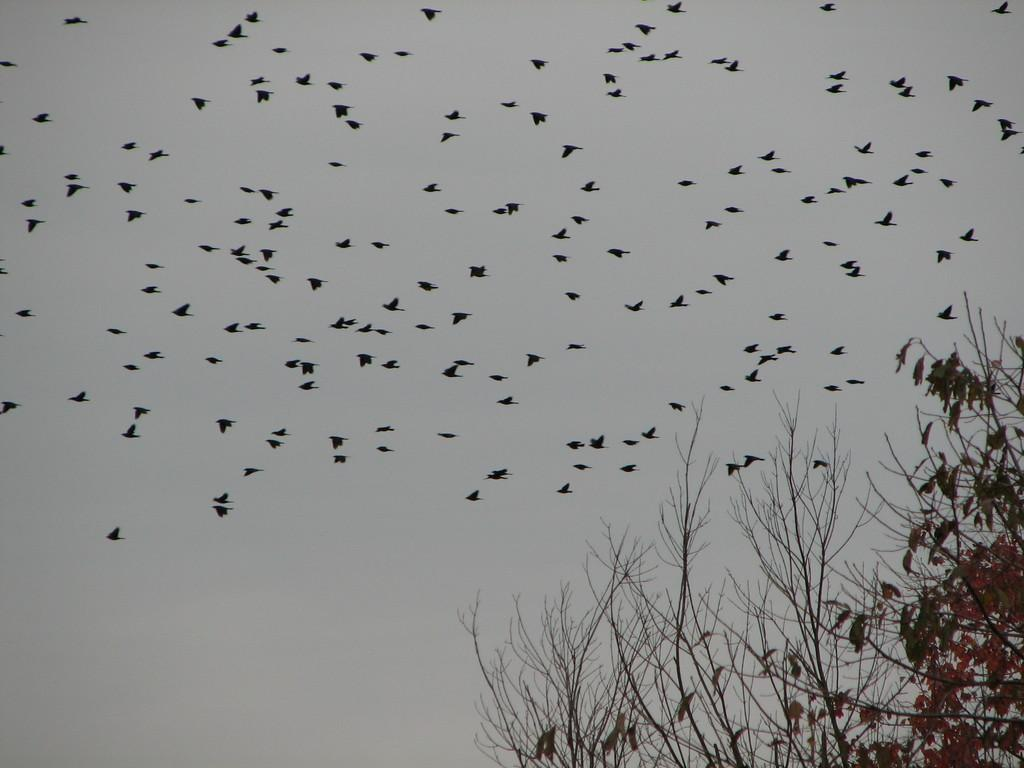What type of animals can be seen in the image? There are birds in the image. What are the birds doing in the image? The birds are flying. What can be seen in the background of the image? There are trees visible in the image. What is visible above the trees in the image? The sky is visible in the image, and clouds are present in the sky. How many sheep are grazing on the stem in the image? There are no sheep or stems present in the image. What type of trade is being conducted by the birds in the image? There is no trade being conducted by the birds in the image; they are simply flying. 